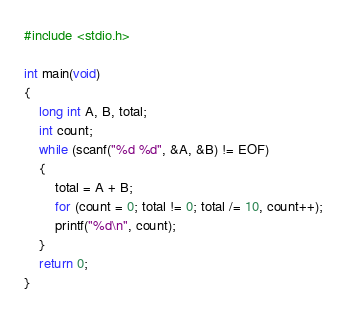<code> <loc_0><loc_0><loc_500><loc_500><_C_>#include <stdio.h>

int main(void)
{
	long int A, B, total;
	int count;
	while (scanf("%d %d", &A, &B) != EOF)
	{
		total = A + B;
		for (count = 0; total != 0; total /= 10, count++);
		printf("%d\n", count);
	}
	return 0;
}</code> 